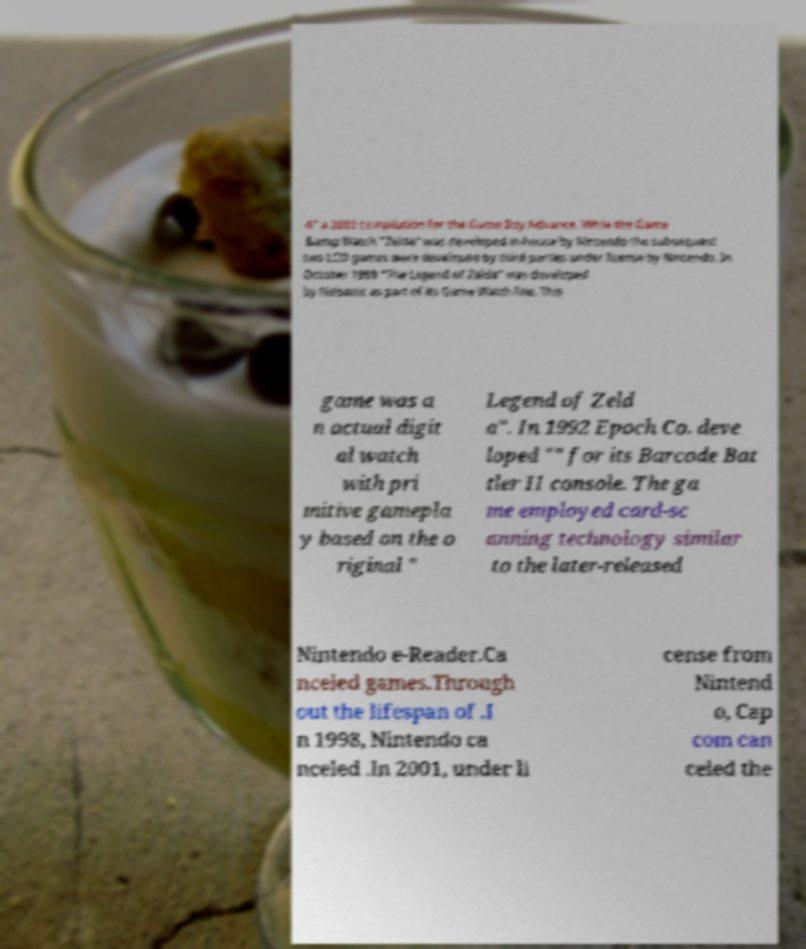Can you accurately transcribe the text from the provided image for me? 4" a 2002 compilation for the Game Boy Advance. While the Game &amp Watch "Zelda" was developed in-house by Nintendo the subsequent two LCD games were developed by third parties under license by Nintendo. In October 1989 "The Legend of Zelda" was developed by Nelsonic as part of its Game Watch line. This game was a n actual digit al watch with pri mitive gamepla y based on the o riginal " Legend of Zeld a". In 1992 Epoch Co. deve loped "" for its Barcode Bat tler II console. The ga me employed card-sc anning technology similar to the later-released Nintendo e-Reader.Ca nceled games.Through out the lifespan of .I n 1998, Nintendo ca nceled .In 2001, under li cense from Nintend o, Cap com can celed the 